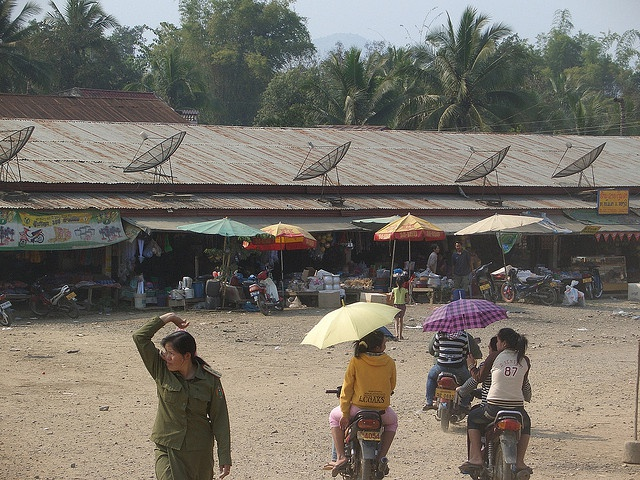Describe the objects in this image and their specific colors. I can see people in purple, black, and gray tones, people in purple, olive, maroon, gray, and black tones, people in purple, black, gray, and darkgray tones, umbrella in purple, beige, lightyellow, and tan tones, and motorcycle in purple, black, gray, and maroon tones in this image. 